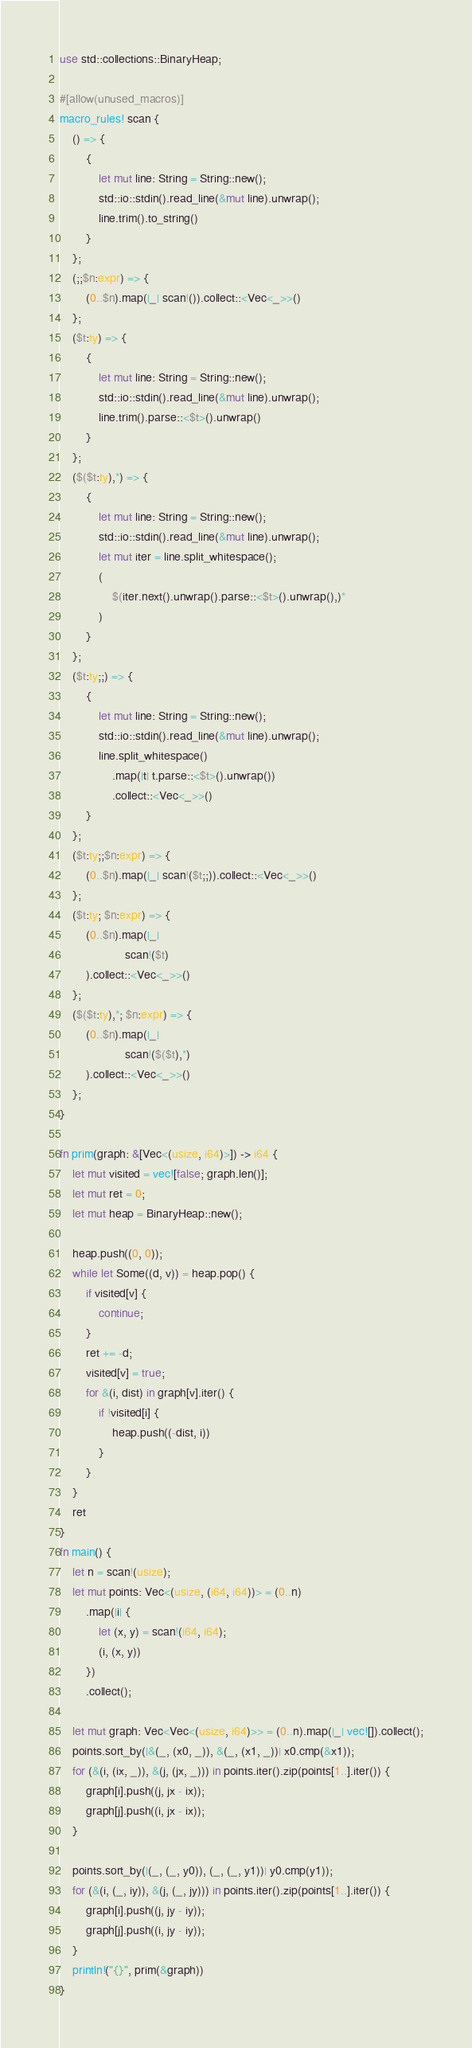<code> <loc_0><loc_0><loc_500><loc_500><_Rust_>use std::collections::BinaryHeap;

#[allow(unused_macros)]
macro_rules! scan {
    () => {
        {
            let mut line: String = String::new();
            std::io::stdin().read_line(&mut line).unwrap();
            line.trim().to_string()
        }
    };
    (;;$n:expr) => {
        (0..$n).map(|_| scan!()).collect::<Vec<_>>()
    };
    ($t:ty) => {
        {
            let mut line: String = String::new();
            std::io::stdin().read_line(&mut line).unwrap();
            line.trim().parse::<$t>().unwrap()
        }
    };
    ($($t:ty),*) => {
        {
            let mut line: String = String::new();
            std::io::stdin().read_line(&mut line).unwrap();
            let mut iter = line.split_whitespace();
            (
                $(iter.next().unwrap().parse::<$t>().unwrap(),)*
            )
        }
    };
    ($t:ty;;) => {
        {
            let mut line: String = String::new();
            std::io::stdin().read_line(&mut line).unwrap();
            line.split_whitespace()
                .map(|t| t.parse::<$t>().unwrap())
                .collect::<Vec<_>>()
        }
    };
    ($t:ty;;$n:expr) => {
        (0..$n).map(|_| scan!($t;;)).collect::<Vec<_>>()
    };
    ($t:ty; $n:expr) => {
        (0..$n).map(|_|
                    scan!($t)
        ).collect::<Vec<_>>()
    };
    ($($t:ty),*; $n:expr) => {
        (0..$n).map(|_|
                    scan!($($t),*)
        ).collect::<Vec<_>>()
    };
}

fn prim(graph: &[Vec<(usize, i64)>]) -> i64 {
    let mut visited = vec![false; graph.len()];
    let mut ret = 0;
    let mut heap = BinaryHeap::new();

    heap.push((0, 0));
    while let Some((d, v)) = heap.pop() {
        if visited[v] {
            continue;
        }
        ret += -d;
        visited[v] = true;
        for &(i, dist) in graph[v].iter() {
            if !visited[i] {
                heap.push((-dist, i))
            }
        }
    }
    ret
}
fn main() {
    let n = scan!(usize);
    let mut points: Vec<(usize, (i64, i64))> = (0..n)
        .map(|i| {
            let (x, y) = scan!(i64, i64);
            (i, (x, y))
        })
        .collect();

    let mut graph: Vec<Vec<(usize, i64)>> = (0..n).map(|_| vec![]).collect();
    points.sort_by(|&(_, (x0, _)), &(_, (x1, _))| x0.cmp(&x1));
    for (&(i, (ix, _)), &(j, (jx, _))) in points.iter().zip(points[1..].iter()) {
        graph[i].push((j, jx - ix));
        graph[j].push((i, jx - ix));
    }

    points.sort_by(|(_, (_, y0)), (_, (_, y1))| y0.cmp(y1));
    for (&(i, (_, iy)), &(j, (_, jy))) in points.iter().zip(points[1..].iter()) {
        graph[i].push((j, jy - iy));
        graph[j].push((i, jy - iy));
    }
    println!("{}", prim(&graph))
}
</code> 